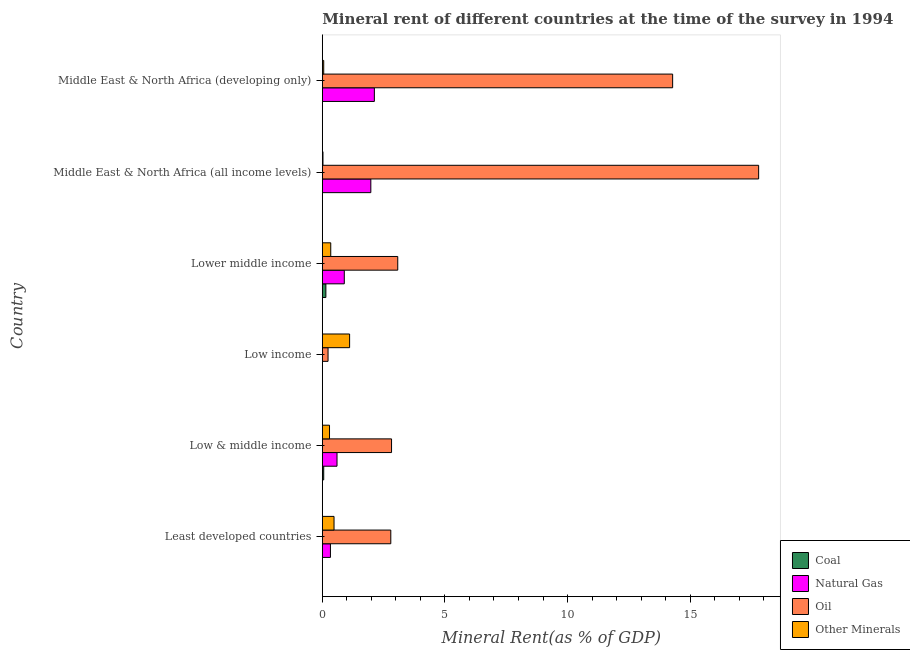How many groups of bars are there?
Keep it short and to the point. 6. Are the number of bars per tick equal to the number of legend labels?
Your answer should be compact. Yes. Are the number of bars on each tick of the Y-axis equal?
Provide a short and direct response. Yes. How many bars are there on the 5th tick from the bottom?
Your response must be concise. 4. What is the label of the 3rd group of bars from the top?
Offer a terse response. Lower middle income. What is the  rent of other minerals in Middle East & North Africa (all income levels)?
Make the answer very short. 0.03. Across all countries, what is the maximum coal rent?
Your response must be concise. 0.14. Across all countries, what is the minimum oil rent?
Provide a succinct answer. 0.23. In which country was the natural gas rent maximum?
Provide a succinct answer. Middle East & North Africa (developing only). In which country was the natural gas rent minimum?
Give a very brief answer. Low income. What is the total natural gas rent in the graph?
Keep it short and to the point. 5.92. What is the difference between the oil rent in Least developed countries and that in Lower middle income?
Provide a succinct answer. -0.28. What is the difference between the coal rent in Middle East & North Africa (all income levels) and the oil rent in Middle East & North Africa (developing only)?
Ensure brevity in your answer.  -14.28. What is the average  rent of other minerals per country?
Provide a short and direct response. 0.39. What is the difference between the coal rent and natural gas rent in Lower middle income?
Your response must be concise. -0.75. What is the ratio of the  rent of other minerals in Least developed countries to that in Middle East & North Africa (developing only)?
Provide a short and direct response. 8.43. Is the difference between the oil rent in Least developed countries and Low & middle income greater than the difference between the  rent of other minerals in Least developed countries and Low & middle income?
Ensure brevity in your answer.  No. What is the difference between the highest and the second highest natural gas rent?
Your answer should be very brief. 0.14. What is the difference between the highest and the lowest  rent of other minerals?
Offer a terse response. 1.09. In how many countries, is the natural gas rent greater than the average natural gas rent taken over all countries?
Provide a succinct answer. 2. Is it the case that in every country, the sum of the natural gas rent and  rent of other minerals is greater than the sum of coal rent and oil rent?
Provide a short and direct response. Yes. What does the 4th bar from the top in Middle East & North Africa (developing only) represents?
Give a very brief answer. Coal. What does the 4th bar from the bottom in Least developed countries represents?
Ensure brevity in your answer.  Other Minerals. Is it the case that in every country, the sum of the coal rent and natural gas rent is greater than the oil rent?
Keep it short and to the point. No. How many bars are there?
Ensure brevity in your answer.  24. Are all the bars in the graph horizontal?
Provide a short and direct response. Yes. How many countries are there in the graph?
Offer a very short reply. 6. What is the difference between two consecutive major ticks on the X-axis?
Give a very brief answer. 5. Are the values on the major ticks of X-axis written in scientific E-notation?
Your response must be concise. No. Does the graph contain any zero values?
Offer a very short reply. No. Does the graph contain grids?
Give a very brief answer. No. How many legend labels are there?
Make the answer very short. 4. What is the title of the graph?
Make the answer very short. Mineral rent of different countries at the time of the survey in 1994. Does "Debt policy" appear as one of the legend labels in the graph?
Keep it short and to the point. No. What is the label or title of the X-axis?
Provide a succinct answer. Mineral Rent(as % of GDP). What is the Mineral Rent(as % of GDP) in Coal in Least developed countries?
Provide a short and direct response. 0. What is the Mineral Rent(as % of GDP) in Natural Gas in Least developed countries?
Provide a short and direct response. 0.33. What is the Mineral Rent(as % of GDP) of Oil in Least developed countries?
Your answer should be very brief. 2.79. What is the Mineral Rent(as % of GDP) of Other Minerals in Least developed countries?
Make the answer very short. 0.48. What is the Mineral Rent(as % of GDP) in Coal in Low & middle income?
Your answer should be compact. 0.06. What is the Mineral Rent(as % of GDP) of Natural Gas in Low & middle income?
Offer a terse response. 0.6. What is the Mineral Rent(as % of GDP) in Oil in Low & middle income?
Your response must be concise. 2.82. What is the Mineral Rent(as % of GDP) in Other Minerals in Low & middle income?
Your answer should be compact. 0.29. What is the Mineral Rent(as % of GDP) of Coal in Low income?
Ensure brevity in your answer.  4.26820971196123e-5. What is the Mineral Rent(as % of GDP) in Natural Gas in Low income?
Your response must be concise. 1.66764618261871e-5. What is the Mineral Rent(as % of GDP) in Oil in Low income?
Your answer should be very brief. 0.23. What is the Mineral Rent(as % of GDP) of Other Minerals in Low income?
Offer a terse response. 1.11. What is the Mineral Rent(as % of GDP) in Coal in Lower middle income?
Ensure brevity in your answer.  0.14. What is the Mineral Rent(as % of GDP) in Natural Gas in Lower middle income?
Ensure brevity in your answer.  0.9. What is the Mineral Rent(as % of GDP) in Oil in Lower middle income?
Your response must be concise. 3.08. What is the Mineral Rent(as % of GDP) of Other Minerals in Lower middle income?
Ensure brevity in your answer.  0.34. What is the Mineral Rent(as % of GDP) of Coal in Middle East & North Africa (all income levels)?
Provide a succinct answer. 0. What is the Mineral Rent(as % of GDP) of Natural Gas in Middle East & North Africa (all income levels)?
Provide a succinct answer. 1.98. What is the Mineral Rent(as % of GDP) of Oil in Middle East & North Africa (all income levels)?
Keep it short and to the point. 17.79. What is the Mineral Rent(as % of GDP) in Other Minerals in Middle East & North Africa (all income levels)?
Your answer should be compact. 0.03. What is the Mineral Rent(as % of GDP) in Coal in Middle East & North Africa (developing only)?
Offer a very short reply. 0. What is the Mineral Rent(as % of GDP) of Natural Gas in Middle East & North Africa (developing only)?
Your answer should be compact. 2.12. What is the Mineral Rent(as % of GDP) in Oil in Middle East & North Africa (developing only)?
Keep it short and to the point. 14.28. What is the Mineral Rent(as % of GDP) in Other Minerals in Middle East & North Africa (developing only)?
Your answer should be compact. 0.06. Across all countries, what is the maximum Mineral Rent(as % of GDP) of Coal?
Your answer should be compact. 0.14. Across all countries, what is the maximum Mineral Rent(as % of GDP) of Natural Gas?
Offer a terse response. 2.12. Across all countries, what is the maximum Mineral Rent(as % of GDP) in Oil?
Offer a terse response. 17.79. Across all countries, what is the maximum Mineral Rent(as % of GDP) of Other Minerals?
Your answer should be very brief. 1.11. Across all countries, what is the minimum Mineral Rent(as % of GDP) in Coal?
Provide a short and direct response. 4.26820971196123e-5. Across all countries, what is the minimum Mineral Rent(as % of GDP) of Natural Gas?
Your answer should be compact. 1.66764618261871e-5. Across all countries, what is the minimum Mineral Rent(as % of GDP) of Oil?
Make the answer very short. 0.23. Across all countries, what is the minimum Mineral Rent(as % of GDP) in Other Minerals?
Provide a succinct answer. 0.03. What is the total Mineral Rent(as % of GDP) of Coal in the graph?
Keep it short and to the point. 0.2. What is the total Mineral Rent(as % of GDP) in Natural Gas in the graph?
Offer a very short reply. 5.92. What is the total Mineral Rent(as % of GDP) in Oil in the graph?
Make the answer very short. 41. What is the total Mineral Rent(as % of GDP) of Other Minerals in the graph?
Your answer should be very brief. 2.31. What is the difference between the Mineral Rent(as % of GDP) of Coal in Least developed countries and that in Low & middle income?
Offer a very short reply. -0.06. What is the difference between the Mineral Rent(as % of GDP) of Natural Gas in Least developed countries and that in Low & middle income?
Keep it short and to the point. -0.27. What is the difference between the Mineral Rent(as % of GDP) in Oil in Least developed countries and that in Low & middle income?
Your response must be concise. -0.03. What is the difference between the Mineral Rent(as % of GDP) of Other Minerals in Least developed countries and that in Low & middle income?
Ensure brevity in your answer.  0.18. What is the difference between the Mineral Rent(as % of GDP) in Coal in Least developed countries and that in Low income?
Ensure brevity in your answer.  0. What is the difference between the Mineral Rent(as % of GDP) of Natural Gas in Least developed countries and that in Low income?
Give a very brief answer. 0.33. What is the difference between the Mineral Rent(as % of GDP) of Oil in Least developed countries and that in Low income?
Provide a short and direct response. 2.56. What is the difference between the Mineral Rent(as % of GDP) in Other Minerals in Least developed countries and that in Low income?
Offer a terse response. -0.64. What is the difference between the Mineral Rent(as % of GDP) of Coal in Least developed countries and that in Lower middle income?
Offer a terse response. -0.14. What is the difference between the Mineral Rent(as % of GDP) in Natural Gas in Least developed countries and that in Lower middle income?
Make the answer very short. -0.56. What is the difference between the Mineral Rent(as % of GDP) of Oil in Least developed countries and that in Lower middle income?
Ensure brevity in your answer.  -0.28. What is the difference between the Mineral Rent(as % of GDP) in Other Minerals in Least developed countries and that in Lower middle income?
Give a very brief answer. 0.13. What is the difference between the Mineral Rent(as % of GDP) in Coal in Least developed countries and that in Middle East & North Africa (all income levels)?
Keep it short and to the point. -0. What is the difference between the Mineral Rent(as % of GDP) in Natural Gas in Least developed countries and that in Middle East & North Africa (all income levels)?
Your answer should be compact. -1.65. What is the difference between the Mineral Rent(as % of GDP) in Other Minerals in Least developed countries and that in Middle East & North Africa (all income levels)?
Keep it short and to the point. 0.45. What is the difference between the Mineral Rent(as % of GDP) of Coal in Least developed countries and that in Middle East & North Africa (developing only)?
Provide a succinct answer. -0. What is the difference between the Mineral Rent(as % of GDP) in Natural Gas in Least developed countries and that in Middle East & North Africa (developing only)?
Your response must be concise. -1.79. What is the difference between the Mineral Rent(as % of GDP) in Oil in Least developed countries and that in Middle East & North Africa (developing only)?
Make the answer very short. -11.49. What is the difference between the Mineral Rent(as % of GDP) of Other Minerals in Least developed countries and that in Middle East & North Africa (developing only)?
Offer a terse response. 0.42. What is the difference between the Mineral Rent(as % of GDP) of Coal in Low & middle income and that in Low income?
Your response must be concise. 0.06. What is the difference between the Mineral Rent(as % of GDP) in Natural Gas in Low & middle income and that in Low income?
Your answer should be very brief. 0.6. What is the difference between the Mineral Rent(as % of GDP) in Oil in Low & middle income and that in Low income?
Your response must be concise. 2.59. What is the difference between the Mineral Rent(as % of GDP) of Other Minerals in Low & middle income and that in Low income?
Ensure brevity in your answer.  -0.82. What is the difference between the Mineral Rent(as % of GDP) of Coal in Low & middle income and that in Lower middle income?
Offer a very short reply. -0.09. What is the difference between the Mineral Rent(as % of GDP) in Natural Gas in Low & middle income and that in Lower middle income?
Ensure brevity in your answer.  -0.3. What is the difference between the Mineral Rent(as % of GDP) of Oil in Low & middle income and that in Lower middle income?
Give a very brief answer. -0.25. What is the difference between the Mineral Rent(as % of GDP) of Other Minerals in Low & middle income and that in Lower middle income?
Your response must be concise. -0.05. What is the difference between the Mineral Rent(as % of GDP) in Coal in Low & middle income and that in Middle East & North Africa (all income levels)?
Keep it short and to the point. 0.06. What is the difference between the Mineral Rent(as % of GDP) of Natural Gas in Low & middle income and that in Middle East & North Africa (all income levels)?
Your answer should be very brief. -1.38. What is the difference between the Mineral Rent(as % of GDP) of Oil in Low & middle income and that in Middle East & North Africa (all income levels)?
Ensure brevity in your answer.  -14.97. What is the difference between the Mineral Rent(as % of GDP) of Other Minerals in Low & middle income and that in Middle East & North Africa (all income levels)?
Your answer should be very brief. 0.27. What is the difference between the Mineral Rent(as % of GDP) in Coal in Low & middle income and that in Middle East & North Africa (developing only)?
Give a very brief answer. 0.05. What is the difference between the Mineral Rent(as % of GDP) in Natural Gas in Low & middle income and that in Middle East & North Africa (developing only)?
Provide a succinct answer. -1.52. What is the difference between the Mineral Rent(as % of GDP) in Oil in Low & middle income and that in Middle East & North Africa (developing only)?
Provide a succinct answer. -11.46. What is the difference between the Mineral Rent(as % of GDP) of Other Minerals in Low & middle income and that in Middle East & North Africa (developing only)?
Give a very brief answer. 0.24. What is the difference between the Mineral Rent(as % of GDP) of Coal in Low income and that in Lower middle income?
Your answer should be compact. -0.14. What is the difference between the Mineral Rent(as % of GDP) of Natural Gas in Low income and that in Lower middle income?
Offer a very short reply. -0.9. What is the difference between the Mineral Rent(as % of GDP) of Oil in Low income and that in Lower middle income?
Provide a short and direct response. -2.84. What is the difference between the Mineral Rent(as % of GDP) of Other Minerals in Low income and that in Lower middle income?
Make the answer very short. 0.77. What is the difference between the Mineral Rent(as % of GDP) in Coal in Low income and that in Middle East & North Africa (all income levels)?
Offer a terse response. -0. What is the difference between the Mineral Rent(as % of GDP) in Natural Gas in Low income and that in Middle East & North Africa (all income levels)?
Offer a very short reply. -1.98. What is the difference between the Mineral Rent(as % of GDP) in Oil in Low income and that in Middle East & North Africa (all income levels)?
Ensure brevity in your answer.  -17.56. What is the difference between the Mineral Rent(as % of GDP) of Other Minerals in Low income and that in Middle East & North Africa (all income levels)?
Your response must be concise. 1.09. What is the difference between the Mineral Rent(as % of GDP) in Coal in Low income and that in Middle East & North Africa (developing only)?
Your answer should be very brief. -0. What is the difference between the Mineral Rent(as % of GDP) in Natural Gas in Low income and that in Middle East & North Africa (developing only)?
Your answer should be very brief. -2.12. What is the difference between the Mineral Rent(as % of GDP) in Oil in Low income and that in Middle East & North Africa (developing only)?
Provide a short and direct response. -14.05. What is the difference between the Mineral Rent(as % of GDP) of Other Minerals in Low income and that in Middle East & North Africa (developing only)?
Make the answer very short. 1.06. What is the difference between the Mineral Rent(as % of GDP) in Coal in Lower middle income and that in Middle East & North Africa (all income levels)?
Your answer should be very brief. 0.14. What is the difference between the Mineral Rent(as % of GDP) of Natural Gas in Lower middle income and that in Middle East & North Africa (all income levels)?
Keep it short and to the point. -1.08. What is the difference between the Mineral Rent(as % of GDP) of Oil in Lower middle income and that in Middle East & North Africa (all income levels)?
Ensure brevity in your answer.  -14.72. What is the difference between the Mineral Rent(as % of GDP) in Other Minerals in Lower middle income and that in Middle East & North Africa (all income levels)?
Provide a succinct answer. 0.32. What is the difference between the Mineral Rent(as % of GDP) in Coal in Lower middle income and that in Middle East & North Africa (developing only)?
Offer a very short reply. 0.14. What is the difference between the Mineral Rent(as % of GDP) of Natural Gas in Lower middle income and that in Middle East & North Africa (developing only)?
Give a very brief answer. -1.23. What is the difference between the Mineral Rent(as % of GDP) of Oil in Lower middle income and that in Middle East & North Africa (developing only)?
Your response must be concise. -11.21. What is the difference between the Mineral Rent(as % of GDP) of Other Minerals in Lower middle income and that in Middle East & North Africa (developing only)?
Ensure brevity in your answer.  0.29. What is the difference between the Mineral Rent(as % of GDP) of Coal in Middle East & North Africa (all income levels) and that in Middle East & North Africa (developing only)?
Provide a short and direct response. -0. What is the difference between the Mineral Rent(as % of GDP) in Natural Gas in Middle East & North Africa (all income levels) and that in Middle East & North Africa (developing only)?
Your answer should be compact. -0.14. What is the difference between the Mineral Rent(as % of GDP) of Oil in Middle East & North Africa (all income levels) and that in Middle East & North Africa (developing only)?
Give a very brief answer. 3.51. What is the difference between the Mineral Rent(as % of GDP) in Other Minerals in Middle East & North Africa (all income levels) and that in Middle East & North Africa (developing only)?
Your answer should be very brief. -0.03. What is the difference between the Mineral Rent(as % of GDP) in Coal in Least developed countries and the Mineral Rent(as % of GDP) in Natural Gas in Low & middle income?
Your answer should be compact. -0.6. What is the difference between the Mineral Rent(as % of GDP) in Coal in Least developed countries and the Mineral Rent(as % of GDP) in Oil in Low & middle income?
Give a very brief answer. -2.82. What is the difference between the Mineral Rent(as % of GDP) of Coal in Least developed countries and the Mineral Rent(as % of GDP) of Other Minerals in Low & middle income?
Give a very brief answer. -0.29. What is the difference between the Mineral Rent(as % of GDP) in Natural Gas in Least developed countries and the Mineral Rent(as % of GDP) in Oil in Low & middle income?
Offer a very short reply. -2.49. What is the difference between the Mineral Rent(as % of GDP) in Natural Gas in Least developed countries and the Mineral Rent(as % of GDP) in Other Minerals in Low & middle income?
Offer a very short reply. 0.04. What is the difference between the Mineral Rent(as % of GDP) in Oil in Least developed countries and the Mineral Rent(as % of GDP) in Other Minerals in Low & middle income?
Offer a terse response. 2.5. What is the difference between the Mineral Rent(as % of GDP) of Coal in Least developed countries and the Mineral Rent(as % of GDP) of Natural Gas in Low income?
Your answer should be very brief. 0. What is the difference between the Mineral Rent(as % of GDP) of Coal in Least developed countries and the Mineral Rent(as % of GDP) of Oil in Low income?
Your response must be concise. -0.23. What is the difference between the Mineral Rent(as % of GDP) in Coal in Least developed countries and the Mineral Rent(as % of GDP) in Other Minerals in Low income?
Your answer should be very brief. -1.11. What is the difference between the Mineral Rent(as % of GDP) of Natural Gas in Least developed countries and the Mineral Rent(as % of GDP) of Oil in Low income?
Provide a short and direct response. 0.1. What is the difference between the Mineral Rent(as % of GDP) in Natural Gas in Least developed countries and the Mineral Rent(as % of GDP) in Other Minerals in Low income?
Ensure brevity in your answer.  -0.78. What is the difference between the Mineral Rent(as % of GDP) of Oil in Least developed countries and the Mineral Rent(as % of GDP) of Other Minerals in Low income?
Give a very brief answer. 1.68. What is the difference between the Mineral Rent(as % of GDP) in Coal in Least developed countries and the Mineral Rent(as % of GDP) in Natural Gas in Lower middle income?
Make the answer very short. -0.9. What is the difference between the Mineral Rent(as % of GDP) in Coal in Least developed countries and the Mineral Rent(as % of GDP) in Oil in Lower middle income?
Keep it short and to the point. -3.08. What is the difference between the Mineral Rent(as % of GDP) in Coal in Least developed countries and the Mineral Rent(as % of GDP) in Other Minerals in Lower middle income?
Keep it short and to the point. -0.34. What is the difference between the Mineral Rent(as % of GDP) of Natural Gas in Least developed countries and the Mineral Rent(as % of GDP) of Oil in Lower middle income?
Offer a very short reply. -2.74. What is the difference between the Mineral Rent(as % of GDP) of Natural Gas in Least developed countries and the Mineral Rent(as % of GDP) of Other Minerals in Lower middle income?
Your answer should be very brief. -0.01. What is the difference between the Mineral Rent(as % of GDP) of Oil in Least developed countries and the Mineral Rent(as % of GDP) of Other Minerals in Lower middle income?
Provide a succinct answer. 2.45. What is the difference between the Mineral Rent(as % of GDP) in Coal in Least developed countries and the Mineral Rent(as % of GDP) in Natural Gas in Middle East & North Africa (all income levels)?
Keep it short and to the point. -1.98. What is the difference between the Mineral Rent(as % of GDP) of Coal in Least developed countries and the Mineral Rent(as % of GDP) of Oil in Middle East & North Africa (all income levels)?
Provide a succinct answer. -17.79. What is the difference between the Mineral Rent(as % of GDP) in Coal in Least developed countries and the Mineral Rent(as % of GDP) in Other Minerals in Middle East & North Africa (all income levels)?
Provide a succinct answer. -0.03. What is the difference between the Mineral Rent(as % of GDP) in Natural Gas in Least developed countries and the Mineral Rent(as % of GDP) in Oil in Middle East & North Africa (all income levels)?
Provide a short and direct response. -17.46. What is the difference between the Mineral Rent(as % of GDP) of Natural Gas in Least developed countries and the Mineral Rent(as % of GDP) of Other Minerals in Middle East & North Africa (all income levels)?
Your answer should be compact. 0.3. What is the difference between the Mineral Rent(as % of GDP) of Oil in Least developed countries and the Mineral Rent(as % of GDP) of Other Minerals in Middle East & North Africa (all income levels)?
Make the answer very short. 2.77. What is the difference between the Mineral Rent(as % of GDP) of Coal in Least developed countries and the Mineral Rent(as % of GDP) of Natural Gas in Middle East & North Africa (developing only)?
Your response must be concise. -2.12. What is the difference between the Mineral Rent(as % of GDP) in Coal in Least developed countries and the Mineral Rent(as % of GDP) in Oil in Middle East & North Africa (developing only)?
Keep it short and to the point. -14.28. What is the difference between the Mineral Rent(as % of GDP) of Coal in Least developed countries and the Mineral Rent(as % of GDP) of Other Minerals in Middle East & North Africa (developing only)?
Give a very brief answer. -0.06. What is the difference between the Mineral Rent(as % of GDP) in Natural Gas in Least developed countries and the Mineral Rent(as % of GDP) in Oil in Middle East & North Africa (developing only)?
Your answer should be compact. -13.95. What is the difference between the Mineral Rent(as % of GDP) of Natural Gas in Least developed countries and the Mineral Rent(as % of GDP) of Other Minerals in Middle East & North Africa (developing only)?
Your answer should be very brief. 0.27. What is the difference between the Mineral Rent(as % of GDP) of Oil in Least developed countries and the Mineral Rent(as % of GDP) of Other Minerals in Middle East & North Africa (developing only)?
Your answer should be compact. 2.74. What is the difference between the Mineral Rent(as % of GDP) of Coal in Low & middle income and the Mineral Rent(as % of GDP) of Natural Gas in Low income?
Keep it short and to the point. 0.06. What is the difference between the Mineral Rent(as % of GDP) in Coal in Low & middle income and the Mineral Rent(as % of GDP) in Oil in Low income?
Provide a short and direct response. -0.18. What is the difference between the Mineral Rent(as % of GDP) in Coal in Low & middle income and the Mineral Rent(as % of GDP) in Other Minerals in Low income?
Give a very brief answer. -1.06. What is the difference between the Mineral Rent(as % of GDP) in Natural Gas in Low & middle income and the Mineral Rent(as % of GDP) in Oil in Low income?
Keep it short and to the point. 0.37. What is the difference between the Mineral Rent(as % of GDP) in Natural Gas in Low & middle income and the Mineral Rent(as % of GDP) in Other Minerals in Low income?
Provide a succinct answer. -0.51. What is the difference between the Mineral Rent(as % of GDP) of Oil in Low & middle income and the Mineral Rent(as % of GDP) of Other Minerals in Low income?
Ensure brevity in your answer.  1.71. What is the difference between the Mineral Rent(as % of GDP) of Coal in Low & middle income and the Mineral Rent(as % of GDP) of Natural Gas in Lower middle income?
Your answer should be compact. -0.84. What is the difference between the Mineral Rent(as % of GDP) in Coal in Low & middle income and the Mineral Rent(as % of GDP) in Oil in Lower middle income?
Offer a terse response. -3.02. What is the difference between the Mineral Rent(as % of GDP) of Coal in Low & middle income and the Mineral Rent(as % of GDP) of Other Minerals in Lower middle income?
Keep it short and to the point. -0.29. What is the difference between the Mineral Rent(as % of GDP) of Natural Gas in Low & middle income and the Mineral Rent(as % of GDP) of Oil in Lower middle income?
Give a very brief answer. -2.48. What is the difference between the Mineral Rent(as % of GDP) of Natural Gas in Low & middle income and the Mineral Rent(as % of GDP) of Other Minerals in Lower middle income?
Keep it short and to the point. 0.26. What is the difference between the Mineral Rent(as % of GDP) in Oil in Low & middle income and the Mineral Rent(as % of GDP) in Other Minerals in Lower middle income?
Offer a very short reply. 2.48. What is the difference between the Mineral Rent(as % of GDP) in Coal in Low & middle income and the Mineral Rent(as % of GDP) in Natural Gas in Middle East & North Africa (all income levels)?
Ensure brevity in your answer.  -1.92. What is the difference between the Mineral Rent(as % of GDP) of Coal in Low & middle income and the Mineral Rent(as % of GDP) of Oil in Middle East & North Africa (all income levels)?
Provide a short and direct response. -17.74. What is the difference between the Mineral Rent(as % of GDP) of Coal in Low & middle income and the Mineral Rent(as % of GDP) of Other Minerals in Middle East & North Africa (all income levels)?
Offer a terse response. 0.03. What is the difference between the Mineral Rent(as % of GDP) in Natural Gas in Low & middle income and the Mineral Rent(as % of GDP) in Oil in Middle East & North Africa (all income levels)?
Ensure brevity in your answer.  -17.19. What is the difference between the Mineral Rent(as % of GDP) of Natural Gas in Low & middle income and the Mineral Rent(as % of GDP) of Other Minerals in Middle East & North Africa (all income levels)?
Your response must be concise. 0.57. What is the difference between the Mineral Rent(as % of GDP) of Oil in Low & middle income and the Mineral Rent(as % of GDP) of Other Minerals in Middle East & North Africa (all income levels)?
Ensure brevity in your answer.  2.8. What is the difference between the Mineral Rent(as % of GDP) of Coal in Low & middle income and the Mineral Rent(as % of GDP) of Natural Gas in Middle East & North Africa (developing only)?
Your answer should be very brief. -2.06. What is the difference between the Mineral Rent(as % of GDP) of Coal in Low & middle income and the Mineral Rent(as % of GDP) of Oil in Middle East & North Africa (developing only)?
Keep it short and to the point. -14.23. What is the difference between the Mineral Rent(as % of GDP) in Coal in Low & middle income and the Mineral Rent(as % of GDP) in Other Minerals in Middle East & North Africa (developing only)?
Ensure brevity in your answer.  -0. What is the difference between the Mineral Rent(as % of GDP) in Natural Gas in Low & middle income and the Mineral Rent(as % of GDP) in Oil in Middle East & North Africa (developing only)?
Your answer should be compact. -13.69. What is the difference between the Mineral Rent(as % of GDP) of Natural Gas in Low & middle income and the Mineral Rent(as % of GDP) of Other Minerals in Middle East & North Africa (developing only)?
Offer a very short reply. 0.54. What is the difference between the Mineral Rent(as % of GDP) of Oil in Low & middle income and the Mineral Rent(as % of GDP) of Other Minerals in Middle East & North Africa (developing only)?
Offer a terse response. 2.77. What is the difference between the Mineral Rent(as % of GDP) of Coal in Low income and the Mineral Rent(as % of GDP) of Natural Gas in Lower middle income?
Ensure brevity in your answer.  -0.9. What is the difference between the Mineral Rent(as % of GDP) of Coal in Low income and the Mineral Rent(as % of GDP) of Oil in Lower middle income?
Provide a short and direct response. -3.08. What is the difference between the Mineral Rent(as % of GDP) of Coal in Low income and the Mineral Rent(as % of GDP) of Other Minerals in Lower middle income?
Provide a short and direct response. -0.34. What is the difference between the Mineral Rent(as % of GDP) in Natural Gas in Low income and the Mineral Rent(as % of GDP) in Oil in Lower middle income?
Provide a succinct answer. -3.08. What is the difference between the Mineral Rent(as % of GDP) of Natural Gas in Low income and the Mineral Rent(as % of GDP) of Other Minerals in Lower middle income?
Keep it short and to the point. -0.34. What is the difference between the Mineral Rent(as % of GDP) in Oil in Low income and the Mineral Rent(as % of GDP) in Other Minerals in Lower middle income?
Provide a succinct answer. -0.11. What is the difference between the Mineral Rent(as % of GDP) of Coal in Low income and the Mineral Rent(as % of GDP) of Natural Gas in Middle East & North Africa (all income levels)?
Make the answer very short. -1.98. What is the difference between the Mineral Rent(as % of GDP) in Coal in Low income and the Mineral Rent(as % of GDP) in Oil in Middle East & North Africa (all income levels)?
Provide a succinct answer. -17.79. What is the difference between the Mineral Rent(as % of GDP) in Coal in Low income and the Mineral Rent(as % of GDP) in Other Minerals in Middle East & North Africa (all income levels)?
Your answer should be very brief. -0.03. What is the difference between the Mineral Rent(as % of GDP) in Natural Gas in Low income and the Mineral Rent(as % of GDP) in Oil in Middle East & North Africa (all income levels)?
Your answer should be very brief. -17.79. What is the difference between the Mineral Rent(as % of GDP) of Natural Gas in Low income and the Mineral Rent(as % of GDP) of Other Minerals in Middle East & North Africa (all income levels)?
Provide a succinct answer. -0.03. What is the difference between the Mineral Rent(as % of GDP) in Oil in Low income and the Mineral Rent(as % of GDP) in Other Minerals in Middle East & North Africa (all income levels)?
Keep it short and to the point. 0.21. What is the difference between the Mineral Rent(as % of GDP) in Coal in Low income and the Mineral Rent(as % of GDP) in Natural Gas in Middle East & North Africa (developing only)?
Offer a very short reply. -2.12. What is the difference between the Mineral Rent(as % of GDP) of Coal in Low income and the Mineral Rent(as % of GDP) of Oil in Middle East & North Africa (developing only)?
Ensure brevity in your answer.  -14.28. What is the difference between the Mineral Rent(as % of GDP) in Coal in Low income and the Mineral Rent(as % of GDP) in Other Minerals in Middle East & North Africa (developing only)?
Provide a short and direct response. -0.06. What is the difference between the Mineral Rent(as % of GDP) in Natural Gas in Low income and the Mineral Rent(as % of GDP) in Oil in Middle East & North Africa (developing only)?
Make the answer very short. -14.28. What is the difference between the Mineral Rent(as % of GDP) in Natural Gas in Low income and the Mineral Rent(as % of GDP) in Other Minerals in Middle East & North Africa (developing only)?
Your response must be concise. -0.06. What is the difference between the Mineral Rent(as % of GDP) in Oil in Low income and the Mineral Rent(as % of GDP) in Other Minerals in Middle East & North Africa (developing only)?
Make the answer very short. 0.18. What is the difference between the Mineral Rent(as % of GDP) in Coal in Lower middle income and the Mineral Rent(as % of GDP) in Natural Gas in Middle East & North Africa (all income levels)?
Your answer should be very brief. -1.83. What is the difference between the Mineral Rent(as % of GDP) in Coal in Lower middle income and the Mineral Rent(as % of GDP) in Oil in Middle East & North Africa (all income levels)?
Provide a short and direct response. -17.65. What is the difference between the Mineral Rent(as % of GDP) of Coal in Lower middle income and the Mineral Rent(as % of GDP) of Other Minerals in Middle East & North Africa (all income levels)?
Offer a very short reply. 0.12. What is the difference between the Mineral Rent(as % of GDP) in Natural Gas in Lower middle income and the Mineral Rent(as % of GDP) in Oil in Middle East & North Africa (all income levels)?
Provide a short and direct response. -16.9. What is the difference between the Mineral Rent(as % of GDP) of Natural Gas in Lower middle income and the Mineral Rent(as % of GDP) of Other Minerals in Middle East & North Africa (all income levels)?
Your answer should be compact. 0.87. What is the difference between the Mineral Rent(as % of GDP) of Oil in Lower middle income and the Mineral Rent(as % of GDP) of Other Minerals in Middle East & North Africa (all income levels)?
Keep it short and to the point. 3.05. What is the difference between the Mineral Rent(as % of GDP) of Coal in Lower middle income and the Mineral Rent(as % of GDP) of Natural Gas in Middle East & North Africa (developing only)?
Provide a succinct answer. -1.98. What is the difference between the Mineral Rent(as % of GDP) in Coal in Lower middle income and the Mineral Rent(as % of GDP) in Oil in Middle East & North Africa (developing only)?
Your answer should be very brief. -14.14. What is the difference between the Mineral Rent(as % of GDP) in Coal in Lower middle income and the Mineral Rent(as % of GDP) in Other Minerals in Middle East & North Africa (developing only)?
Offer a terse response. 0.09. What is the difference between the Mineral Rent(as % of GDP) in Natural Gas in Lower middle income and the Mineral Rent(as % of GDP) in Oil in Middle East & North Africa (developing only)?
Keep it short and to the point. -13.39. What is the difference between the Mineral Rent(as % of GDP) in Natural Gas in Lower middle income and the Mineral Rent(as % of GDP) in Other Minerals in Middle East & North Africa (developing only)?
Provide a short and direct response. 0.84. What is the difference between the Mineral Rent(as % of GDP) of Oil in Lower middle income and the Mineral Rent(as % of GDP) of Other Minerals in Middle East & North Africa (developing only)?
Your response must be concise. 3.02. What is the difference between the Mineral Rent(as % of GDP) of Coal in Middle East & North Africa (all income levels) and the Mineral Rent(as % of GDP) of Natural Gas in Middle East & North Africa (developing only)?
Ensure brevity in your answer.  -2.12. What is the difference between the Mineral Rent(as % of GDP) of Coal in Middle East & North Africa (all income levels) and the Mineral Rent(as % of GDP) of Oil in Middle East & North Africa (developing only)?
Your answer should be compact. -14.28. What is the difference between the Mineral Rent(as % of GDP) of Coal in Middle East & North Africa (all income levels) and the Mineral Rent(as % of GDP) of Other Minerals in Middle East & North Africa (developing only)?
Give a very brief answer. -0.06. What is the difference between the Mineral Rent(as % of GDP) of Natural Gas in Middle East & North Africa (all income levels) and the Mineral Rent(as % of GDP) of Oil in Middle East & North Africa (developing only)?
Keep it short and to the point. -12.31. What is the difference between the Mineral Rent(as % of GDP) of Natural Gas in Middle East & North Africa (all income levels) and the Mineral Rent(as % of GDP) of Other Minerals in Middle East & North Africa (developing only)?
Provide a short and direct response. 1.92. What is the difference between the Mineral Rent(as % of GDP) in Oil in Middle East & North Africa (all income levels) and the Mineral Rent(as % of GDP) in Other Minerals in Middle East & North Africa (developing only)?
Give a very brief answer. 17.74. What is the average Mineral Rent(as % of GDP) of Coal per country?
Your answer should be compact. 0.03. What is the average Mineral Rent(as % of GDP) in Natural Gas per country?
Give a very brief answer. 0.99. What is the average Mineral Rent(as % of GDP) of Oil per country?
Offer a very short reply. 6.83. What is the average Mineral Rent(as % of GDP) in Other Minerals per country?
Provide a succinct answer. 0.39. What is the difference between the Mineral Rent(as % of GDP) of Coal and Mineral Rent(as % of GDP) of Natural Gas in Least developed countries?
Your answer should be compact. -0.33. What is the difference between the Mineral Rent(as % of GDP) in Coal and Mineral Rent(as % of GDP) in Oil in Least developed countries?
Your answer should be very brief. -2.79. What is the difference between the Mineral Rent(as % of GDP) in Coal and Mineral Rent(as % of GDP) in Other Minerals in Least developed countries?
Ensure brevity in your answer.  -0.48. What is the difference between the Mineral Rent(as % of GDP) of Natural Gas and Mineral Rent(as % of GDP) of Oil in Least developed countries?
Provide a short and direct response. -2.46. What is the difference between the Mineral Rent(as % of GDP) in Natural Gas and Mineral Rent(as % of GDP) in Other Minerals in Least developed countries?
Your response must be concise. -0.15. What is the difference between the Mineral Rent(as % of GDP) of Oil and Mineral Rent(as % of GDP) of Other Minerals in Least developed countries?
Give a very brief answer. 2.31. What is the difference between the Mineral Rent(as % of GDP) of Coal and Mineral Rent(as % of GDP) of Natural Gas in Low & middle income?
Give a very brief answer. -0.54. What is the difference between the Mineral Rent(as % of GDP) of Coal and Mineral Rent(as % of GDP) of Oil in Low & middle income?
Make the answer very short. -2.77. What is the difference between the Mineral Rent(as % of GDP) of Coal and Mineral Rent(as % of GDP) of Other Minerals in Low & middle income?
Provide a short and direct response. -0.24. What is the difference between the Mineral Rent(as % of GDP) of Natural Gas and Mineral Rent(as % of GDP) of Oil in Low & middle income?
Offer a very short reply. -2.22. What is the difference between the Mineral Rent(as % of GDP) of Natural Gas and Mineral Rent(as % of GDP) of Other Minerals in Low & middle income?
Provide a short and direct response. 0.31. What is the difference between the Mineral Rent(as % of GDP) in Oil and Mineral Rent(as % of GDP) in Other Minerals in Low & middle income?
Give a very brief answer. 2.53. What is the difference between the Mineral Rent(as % of GDP) in Coal and Mineral Rent(as % of GDP) in Oil in Low income?
Provide a succinct answer. -0.23. What is the difference between the Mineral Rent(as % of GDP) in Coal and Mineral Rent(as % of GDP) in Other Minerals in Low income?
Provide a short and direct response. -1.11. What is the difference between the Mineral Rent(as % of GDP) in Natural Gas and Mineral Rent(as % of GDP) in Oil in Low income?
Your answer should be compact. -0.23. What is the difference between the Mineral Rent(as % of GDP) of Natural Gas and Mineral Rent(as % of GDP) of Other Minerals in Low income?
Offer a terse response. -1.11. What is the difference between the Mineral Rent(as % of GDP) in Oil and Mineral Rent(as % of GDP) in Other Minerals in Low income?
Provide a succinct answer. -0.88. What is the difference between the Mineral Rent(as % of GDP) of Coal and Mineral Rent(as % of GDP) of Natural Gas in Lower middle income?
Provide a succinct answer. -0.75. What is the difference between the Mineral Rent(as % of GDP) of Coal and Mineral Rent(as % of GDP) of Oil in Lower middle income?
Offer a very short reply. -2.93. What is the difference between the Mineral Rent(as % of GDP) of Coal and Mineral Rent(as % of GDP) of Other Minerals in Lower middle income?
Offer a terse response. -0.2. What is the difference between the Mineral Rent(as % of GDP) in Natural Gas and Mineral Rent(as % of GDP) in Oil in Lower middle income?
Your answer should be compact. -2.18. What is the difference between the Mineral Rent(as % of GDP) of Natural Gas and Mineral Rent(as % of GDP) of Other Minerals in Lower middle income?
Give a very brief answer. 0.55. What is the difference between the Mineral Rent(as % of GDP) of Oil and Mineral Rent(as % of GDP) of Other Minerals in Lower middle income?
Give a very brief answer. 2.73. What is the difference between the Mineral Rent(as % of GDP) of Coal and Mineral Rent(as % of GDP) of Natural Gas in Middle East & North Africa (all income levels)?
Offer a terse response. -1.98. What is the difference between the Mineral Rent(as % of GDP) in Coal and Mineral Rent(as % of GDP) in Oil in Middle East & North Africa (all income levels)?
Offer a terse response. -17.79. What is the difference between the Mineral Rent(as % of GDP) of Coal and Mineral Rent(as % of GDP) of Other Minerals in Middle East & North Africa (all income levels)?
Give a very brief answer. -0.03. What is the difference between the Mineral Rent(as % of GDP) in Natural Gas and Mineral Rent(as % of GDP) in Oil in Middle East & North Africa (all income levels)?
Give a very brief answer. -15.81. What is the difference between the Mineral Rent(as % of GDP) in Natural Gas and Mineral Rent(as % of GDP) in Other Minerals in Middle East & North Africa (all income levels)?
Your response must be concise. 1.95. What is the difference between the Mineral Rent(as % of GDP) in Oil and Mineral Rent(as % of GDP) in Other Minerals in Middle East & North Africa (all income levels)?
Your answer should be compact. 17.77. What is the difference between the Mineral Rent(as % of GDP) in Coal and Mineral Rent(as % of GDP) in Natural Gas in Middle East & North Africa (developing only)?
Keep it short and to the point. -2.12. What is the difference between the Mineral Rent(as % of GDP) in Coal and Mineral Rent(as % of GDP) in Oil in Middle East & North Africa (developing only)?
Offer a terse response. -14.28. What is the difference between the Mineral Rent(as % of GDP) in Coal and Mineral Rent(as % of GDP) in Other Minerals in Middle East & North Africa (developing only)?
Your answer should be compact. -0.05. What is the difference between the Mineral Rent(as % of GDP) in Natural Gas and Mineral Rent(as % of GDP) in Oil in Middle East & North Africa (developing only)?
Make the answer very short. -12.16. What is the difference between the Mineral Rent(as % of GDP) in Natural Gas and Mineral Rent(as % of GDP) in Other Minerals in Middle East & North Africa (developing only)?
Make the answer very short. 2.06. What is the difference between the Mineral Rent(as % of GDP) in Oil and Mineral Rent(as % of GDP) in Other Minerals in Middle East & North Africa (developing only)?
Your response must be concise. 14.23. What is the ratio of the Mineral Rent(as % of GDP) of Coal in Least developed countries to that in Low & middle income?
Offer a very short reply. 0. What is the ratio of the Mineral Rent(as % of GDP) of Natural Gas in Least developed countries to that in Low & middle income?
Your response must be concise. 0.55. What is the ratio of the Mineral Rent(as % of GDP) of Oil in Least developed countries to that in Low & middle income?
Make the answer very short. 0.99. What is the ratio of the Mineral Rent(as % of GDP) of Other Minerals in Least developed countries to that in Low & middle income?
Provide a succinct answer. 1.63. What is the ratio of the Mineral Rent(as % of GDP) in Coal in Least developed countries to that in Low income?
Give a very brief answer. 5.93. What is the ratio of the Mineral Rent(as % of GDP) in Natural Gas in Least developed countries to that in Low income?
Your answer should be compact. 1.98e+04. What is the ratio of the Mineral Rent(as % of GDP) in Oil in Least developed countries to that in Low income?
Ensure brevity in your answer.  11.96. What is the ratio of the Mineral Rent(as % of GDP) in Other Minerals in Least developed countries to that in Low income?
Offer a terse response. 0.43. What is the ratio of the Mineral Rent(as % of GDP) in Coal in Least developed countries to that in Lower middle income?
Give a very brief answer. 0. What is the ratio of the Mineral Rent(as % of GDP) in Natural Gas in Least developed countries to that in Lower middle income?
Provide a short and direct response. 0.37. What is the ratio of the Mineral Rent(as % of GDP) in Oil in Least developed countries to that in Lower middle income?
Offer a very short reply. 0.91. What is the ratio of the Mineral Rent(as % of GDP) in Other Minerals in Least developed countries to that in Lower middle income?
Make the answer very short. 1.39. What is the ratio of the Mineral Rent(as % of GDP) in Coal in Least developed countries to that in Middle East & North Africa (all income levels)?
Offer a very short reply. 0.26. What is the ratio of the Mineral Rent(as % of GDP) of Natural Gas in Least developed countries to that in Middle East & North Africa (all income levels)?
Your response must be concise. 0.17. What is the ratio of the Mineral Rent(as % of GDP) in Oil in Least developed countries to that in Middle East & North Africa (all income levels)?
Offer a very short reply. 0.16. What is the ratio of the Mineral Rent(as % of GDP) in Other Minerals in Least developed countries to that in Middle East & North Africa (all income levels)?
Offer a terse response. 17.74. What is the ratio of the Mineral Rent(as % of GDP) of Coal in Least developed countries to that in Middle East & North Africa (developing only)?
Provide a succinct answer. 0.12. What is the ratio of the Mineral Rent(as % of GDP) of Natural Gas in Least developed countries to that in Middle East & North Africa (developing only)?
Keep it short and to the point. 0.16. What is the ratio of the Mineral Rent(as % of GDP) of Oil in Least developed countries to that in Middle East & North Africa (developing only)?
Keep it short and to the point. 0.2. What is the ratio of the Mineral Rent(as % of GDP) in Other Minerals in Least developed countries to that in Middle East & North Africa (developing only)?
Keep it short and to the point. 8.43. What is the ratio of the Mineral Rent(as % of GDP) in Coal in Low & middle income to that in Low income?
Keep it short and to the point. 1323.33. What is the ratio of the Mineral Rent(as % of GDP) of Natural Gas in Low & middle income to that in Low income?
Ensure brevity in your answer.  3.59e+04. What is the ratio of the Mineral Rent(as % of GDP) of Oil in Low & middle income to that in Low income?
Your response must be concise. 12.09. What is the ratio of the Mineral Rent(as % of GDP) in Other Minerals in Low & middle income to that in Low income?
Offer a terse response. 0.26. What is the ratio of the Mineral Rent(as % of GDP) of Coal in Low & middle income to that in Lower middle income?
Give a very brief answer. 0.39. What is the ratio of the Mineral Rent(as % of GDP) of Natural Gas in Low & middle income to that in Lower middle income?
Ensure brevity in your answer.  0.67. What is the ratio of the Mineral Rent(as % of GDP) of Oil in Low & middle income to that in Lower middle income?
Provide a short and direct response. 0.92. What is the ratio of the Mineral Rent(as % of GDP) of Other Minerals in Low & middle income to that in Lower middle income?
Provide a succinct answer. 0.85. What is the ratio of the Mineral Rent(as % of GDP) in Coal in Low & middle income to that in Middle East & North Africa (all income levels)?
Keep it short and to the point. 58.3. What is the ratio of the Mineral Rent(as % of GDP) in Natural Gas in Low & middle income to that in Middle East & North Africa (all income levels)?
Keep it short and to the point. 0.3. What is the ratio of the Mineral Rent(as % of GDP) in Oil in Low & middle income to that in Middle East & North Africa (all income levels)?
Provide a short and direct response. 0.16. What is the ratio of the Mineral Rent(as % of GDP) in Other Minerals in Low & middle income to that in Middle East & North Africa (all income levels)?
Your answer should be compact. 10.9. What is the ratio of the Mineral Rent(as % of GDP) in Coal in Low & middle income to that in Middle East & North Africa (developing only)?
Provide a short and direct response. 27.02. What is the ratio of the Mineral Rent(as % of GDP) of Natural Gas in Low & middle income to that in Middle East & North Africa (developing only)?
Provide a succinct answer. 0.28. What is the ratio of the Mineral Rent(as % of GDP) of Oil in Low & middle income to that in Middle East & North Africa (developing only)?
Keep it short and to the point. 0.2. What is the ratio of the Mineral Rent(as % of GDP) of Other Minerals in Low & middle income to that in Middle East & North Africa (developing only)?
Provide a succinct answer. 5.18. What is the ratio of the Mineral Rent(as % of GDP) of Coal in Low income to that in Lower middle income?
Ensure brevity in your answer.  0. What is the ratio of the Mineral Rent(as % of GDP) of Natural Gas in Low income to that in Lower middle income?
Offer a terse response. 0. What is the ratio of the Mineral Rent(as % of GDP) in Oil in Low income to that in Lower middle income?
Make the answer very short. 0.08. What is the ratio of the Mineral Rent(as % of GDP) of Other Minerals in Low income to that in Lower middle income?
Offer a very short reply. 3.24. What is the ratio of the Mineral Rent(as % of GDP) of Coal in Low income to that in Middle East & North Africa (all income levels)?
Your response must be concise. 0.04. What is the ratio of the Mineral Rent(as % of GDP) in Oil in Low income to that in Middle East & North Africa (all income levels)?
Your answer should be compact. 0.01. What is the ratio of the Mineral Rent(as % of GDP) in Other Minerals in Low income to that in Middle East & North Africa (all income levels)?
Your answer should be compact. 41.33. What is the ratio of the Mineral Rent(as % of GDP) in Coal in Low income to that in Middle East & North Africa (developing only)?
Your response must be concise. 0.02. What is the ratio of the Mineral Rent(as % of GDP) of Natural Gas in Low income to that in Middle East & North Africa (developing only)?
Your answer should be very brief. 0. What is the ratio of the Mineral Rent(as % of GDP) of Oil in Low income to that in Middle East & North Africa (developing only)?
Ensure brevity in your answer.  0.02. What is the ratio of the Mineral Rent(as % of GDP) of Other Minerals in Low income to that in Middle East & North Africa (developing only)?
Ensure brevity in your answer.  19.65. What is the ratio of the Mineral Rent(as % of GDP) in Coal in Lower middle income to that in Middle East & North Africa (all income levels)?
Your answer should be very brief. 149.4. What is the ratio of the Mineral Rent(as % of GDP) in Natural Gas in Lower middle income to that in Middle East & North Africa (all income levels)?
Provide a succinct answer. 0.45. What is the ratio of the Mineral Rent(as % of GDP) in Oil in Lower middle income to that in Middle East & North Africa (all income levels)?
Offer a terse response. 0.17. What is the ratio of the Mineral Rent(as % of GDP) in Other Minerals in Lower middle income to that in Middle East & North Africa (all income levels)?
Your answer should be very brief. 12.76. What is the ratio of the Mineral Rent(as % of GDP) in Coal in Lower middle income to that in Middle East & North Africa (developing only)?
Provide a succinct answer. 69.23. What is the ratio of the Mineral Rent(as % of GDP) of Natural Gas in Lower middle income to that in Middle East & North Africa (developing only)?
Provide a succinct answer. 0.42. What is the ratio of the Mineral Rent(as % of GDP) in Oil in Lower middle income to that in Middle East & North Africa (developing only)?
Ensure brevity in your answer.  0.22. What is the ratio of the Mineral Rent(as % of GDP) in Other Minerals in Lower middle income to that in Middle East & North Africa (developing only)?
Your response must be concise. 6.07. What is the ratio of the Mineral Rent(as % of GDP) in Coal in Middle East & North Africa (all income levels) to that in Middle East & North Africa (developing only)?
Your answer should be very brief. 0.46. What is the ratio of the Mineral Rent(as % of GDP) in Natural Gas in Middle East & North Africa (all income levels) to that in Middle East & North Africa (developing only)?
Ensure brevity in your answer.  0.93. What is the ratio of the Mineral Rent(as % of GDP) in Oil in Middle East & North Africa (all income levels) to that in Middle East & North Africa (developing only)?
Your answer should be very brief. 1.25. What is the ratio of the Mineral Rent(as % of GDP) in Other Minerals in Middle East & North Africa (all income levels) to that in Middle East & North Africa (developing only)?
Provide a succinct answer. 0.48. What is the difference between the highest and the second highest Mineral Rent(as % of GDP) in Coal?
Ensure brevity in your answer.  0.09. What is the difference between the highest and the second highest Mineral Rent(as % of GDP) of Natural Gas?
Your answer should be compact. 0.14. What is the difference between the highest and the second highest Mineral Rent(as % of GDP) in Oil?
Provide a succinct answer. 3.51. What is the difference between the highest and the second highest Mineral Rent(as % of GDP) in Other Minerals?
Offer a terse response. 0.64. What is the difference between the highest and the lowest Mineral Rent(as % of GDP) in Coal?
Your answer should be compact. 0.14. What is the difference between the highest and the lowest Mineral Rent(as % of GDP) of Natural Gas?
Provide a succinct answer. 2.12. What is the difference between the highest and the lowest Mineral Rent(as % of GDP) in Oil?
Make the answer very short. 17.56. What is the difference between the highest and the lowest Mineral Rent(as % of GDP) in Other Minerals?
Provide a succinct answer. 1.09. 